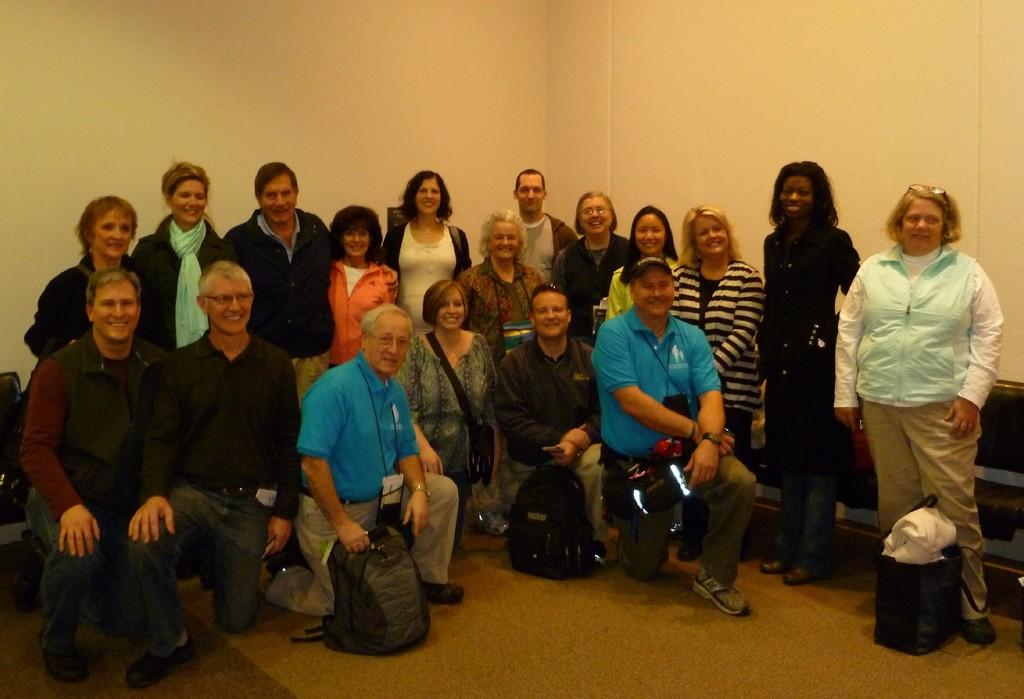How many people are in the group in the image? There is a group of people in the image, but the exact number is not specified. What are some of the people in the group doing? Some people in the group are smiling, while others are standing or sitting on the floor. What objects can be seen near the people in the image? There are bags visible in the image. What is visible in the background of the image? There is a wall in the background of the image. What type of cord is being used to hang the curtains in the image? There are no curtains or cords present in the image; it features a group of people with bags and a wall in the background. 